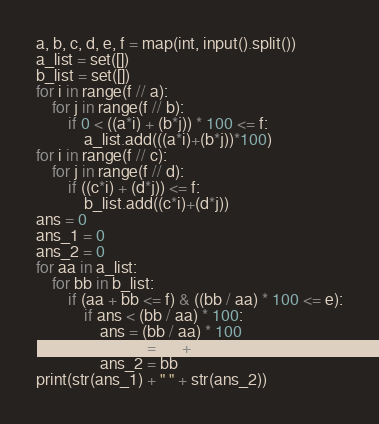Convert code to text. <code><loc_0><loc_0><loc_500><loc_500><_Python_>a, b, c, d, e, f = map(int, input().split())
a_list = set([])
b_list = set([])
for i in range(f // a):
    for j in range(f // b):
        if 0 < ((a*i) + (b*j)) * 100 <= f:
            a_list.add(((a*i)+(b*j))*100)
for i in range(f // c):
    for j in range(f // d):
        if ((c*i) + (d*j)) <= f:
            b_list.add((c*i)+(d*j))
ans = 0
ans_1 = 0
ans_2 = 0
for aa in a_list:
    for bb in b_list:
        if (aa + bb <= f) & ((bb / aa) * 100 <= e):
            if ans < (bb / aa) * 100:
                ans = (bb / aa) * 100
                ans_1 = aa + bb
                ans_2 = bb
print(str(ans_1) + " " + str(ans_2))</code> 